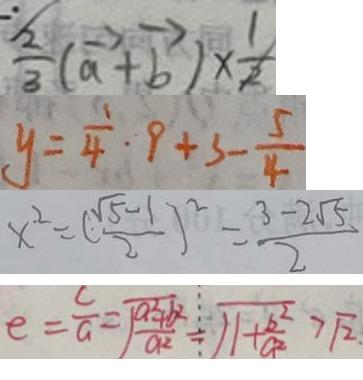Convert formula to latex. <formula><loc_0><loc_0><loc_500><loc_500>\frac { 2 } { 3 } ( \overrightarrow { a } + \overrightarrow { b } ) \times \frac { 1 } { 2 } 
 y = \frac { 1 } { 4 } \cdot 9 + 3 - \frac { 5 } { 4 } 
 x ^ { 2 } = ( \frac { \sqrt { 5 } - 1 } { 2 } ) ^ { 2 } = \frac { 3 - 2 \sqrt { 5 } } { 2 } 
 e = \frac { c } { a } = \sqrt { \frac { a ^ { 2 } + b ^ { 2 } } { a ^ { 2 } } } = \sqrt { 1 + \frac { b ^ { 2 } } { a ^ { 2 } } } > \sqrt { 2 } \cdot</formula> 